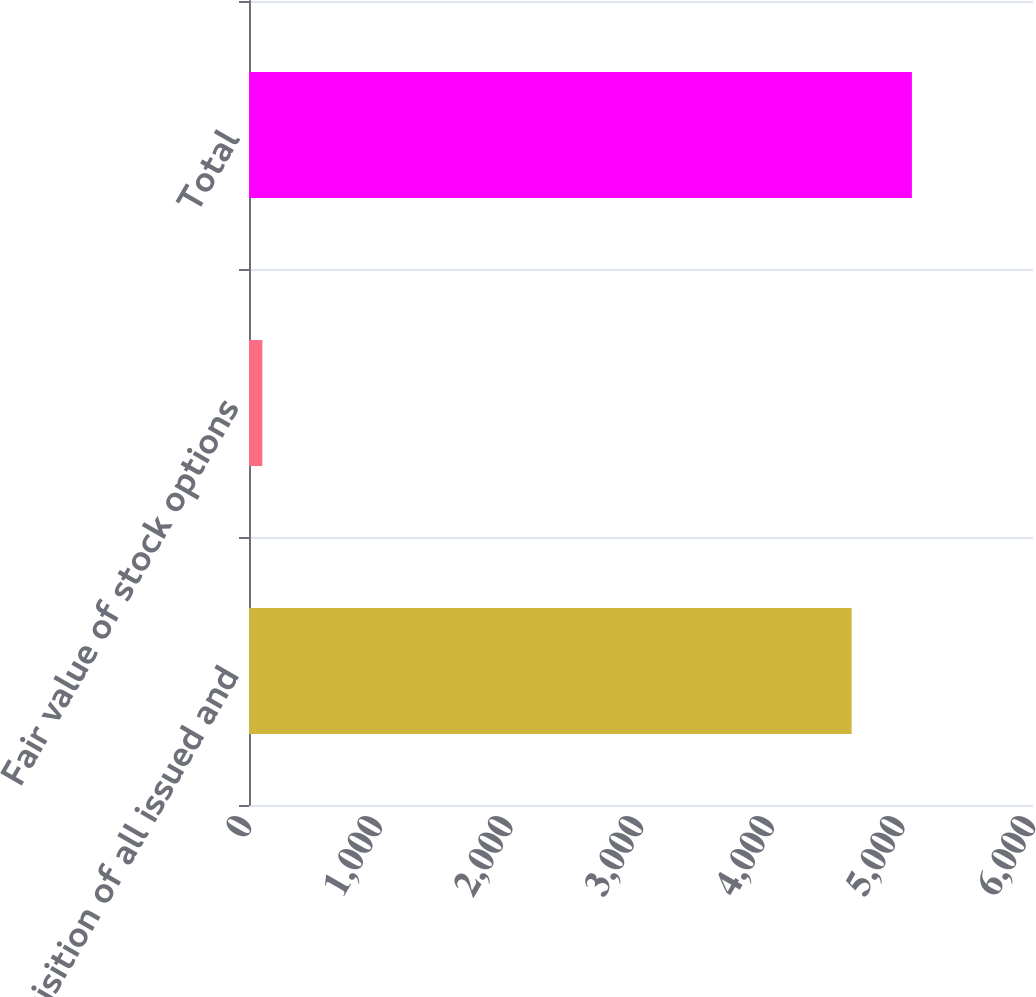Convert chart. <chart><loc_0><loc_0><loc_500><loc_500><bar_chart><fcel>Acquisition of all issued and<fcel>Fair value of stock options<fcel>Total<nl><fcel>4612<fcel>102<fcel>5073.2<nl></chart> 